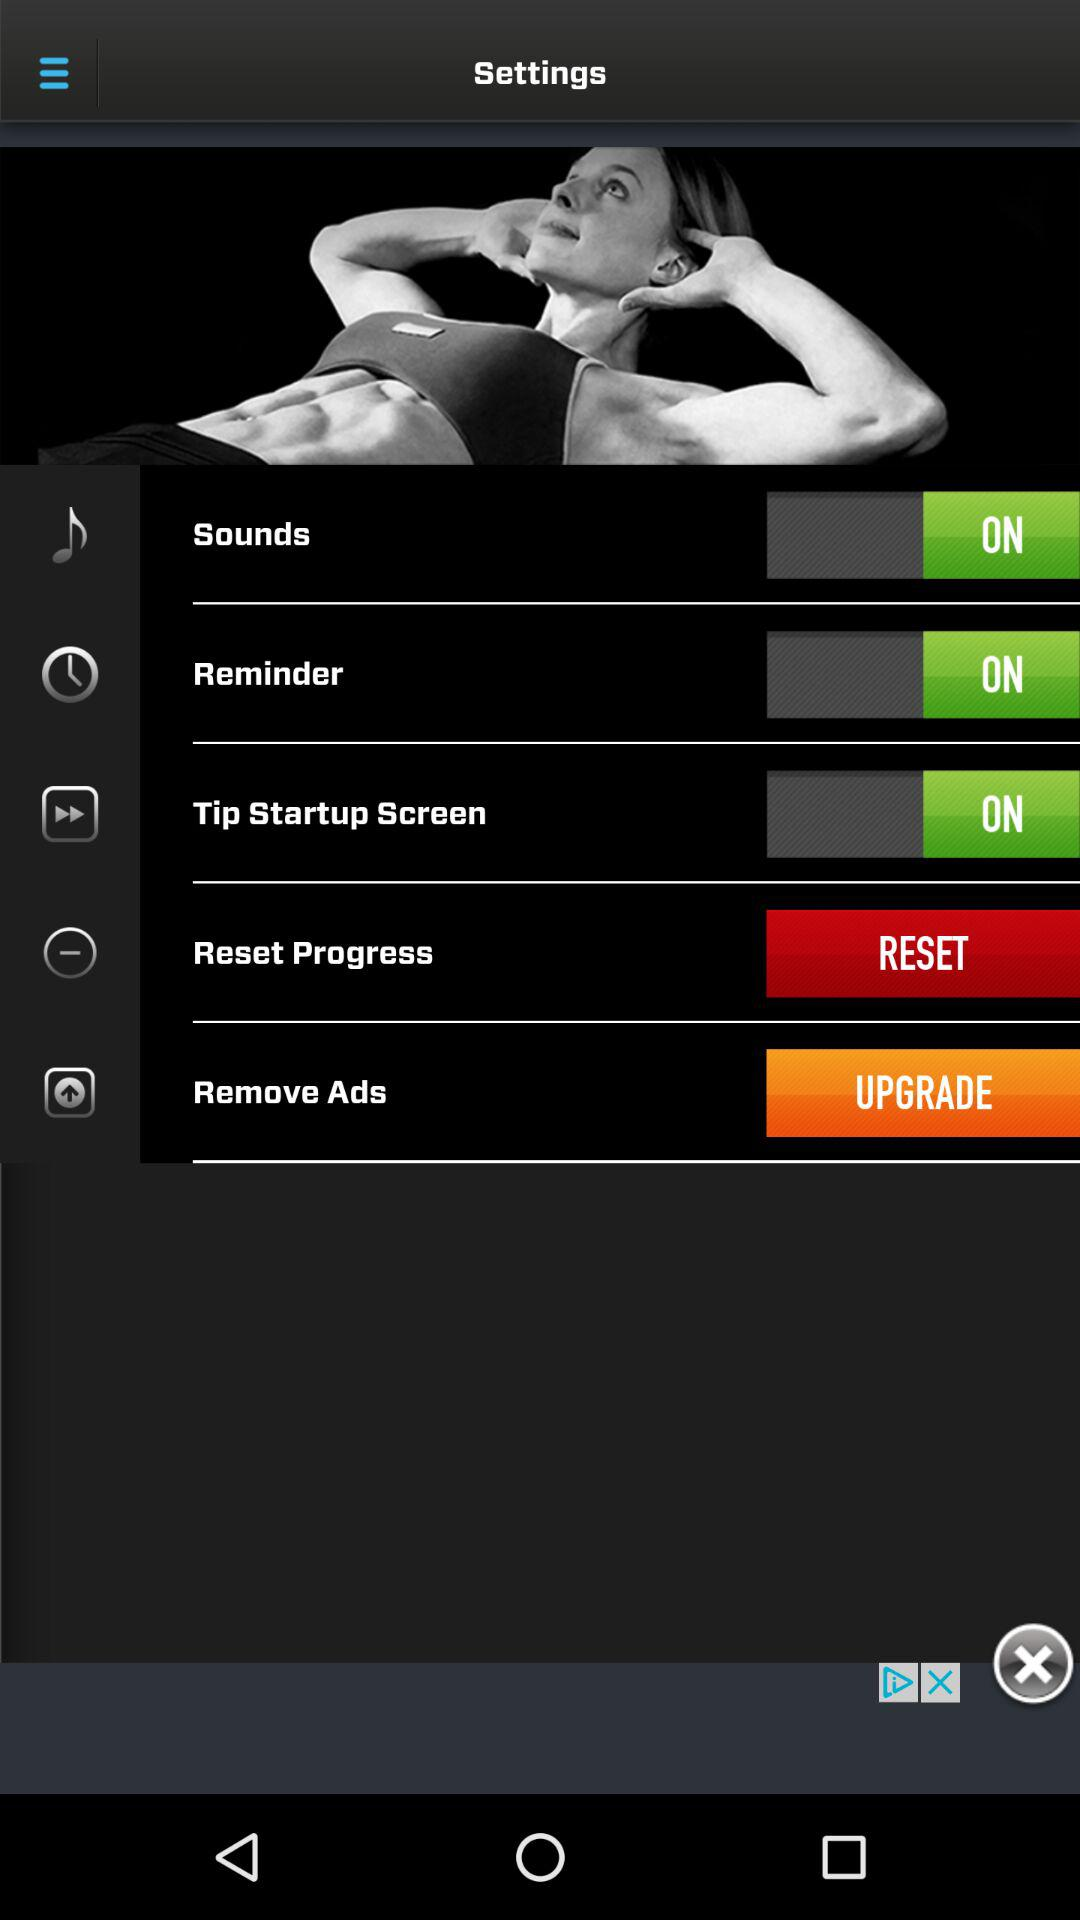What is the status of the "Tip Startup Screen" setting? The status is "on". 